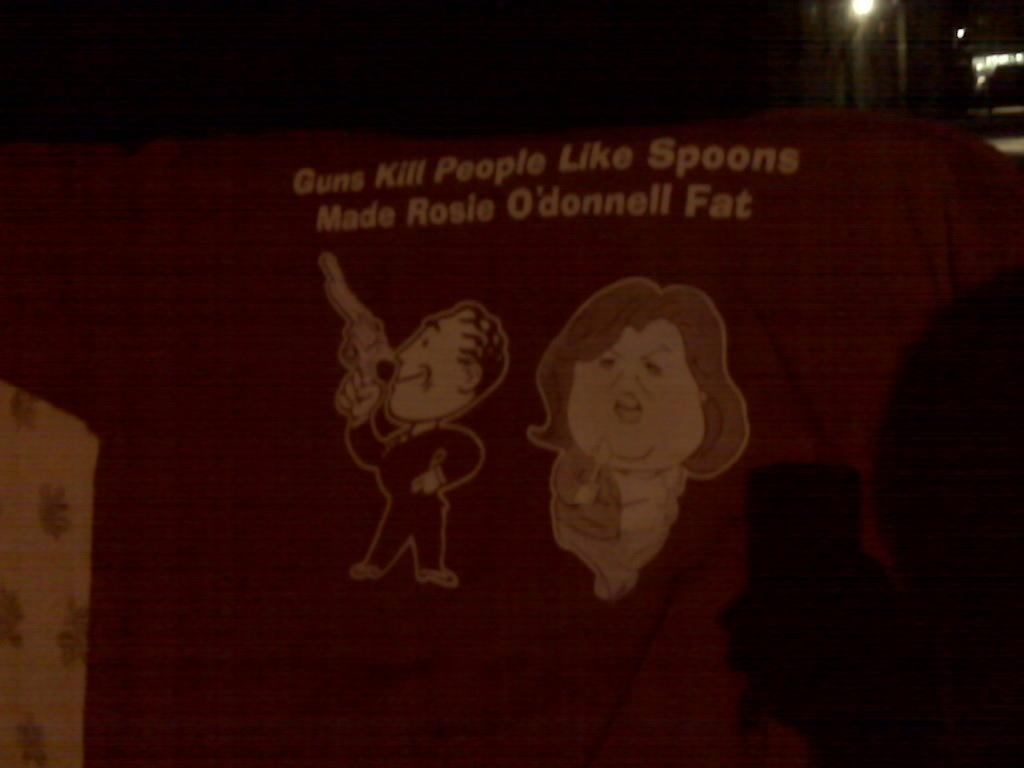What type of images can be seen in the picture? There are two animated images in the picture. Can you describe any text or writing in the picture? Yes, there is a quotation written on a red background in the picture. Where is the coil located in the picture? There is no coil present in the picture. What type of bun is being held by one of the animated characters? There are no buns or animated characters holding buns in the picture. 